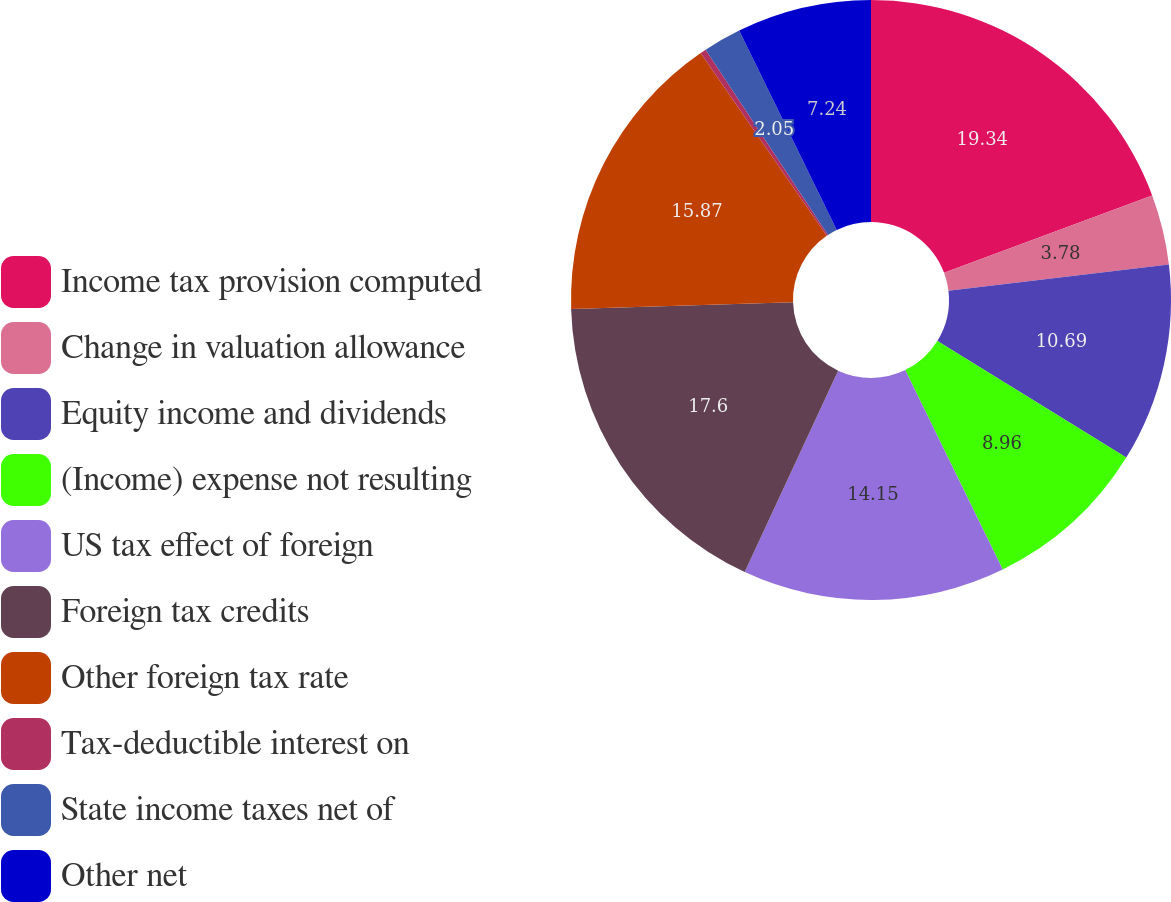<chart> <loc_0><loc_0><loc_500><loc_500><pie_chart><fcel>Income tax provision computed<fcel>Change in valuation allowance<fcel>Equity income and dividends<fcel>(Income) expense not resulting<fcel>US tax effect of foreign<fcel>Foreign tax credits<fcel>Other foreign tax rate<fcel>Tax-deductible interest on<fcel>State income taxes net of<fcel>Other net<nl><fcel>19.33%<fcel>3.78%<fcel>10.69%<fcel>8.96%<fcel>14.15%<fcel>17.6%<fcel>15.87%<fcel>0.32%<fcel>2.05%<fcel>7.24%<nl></chart> 